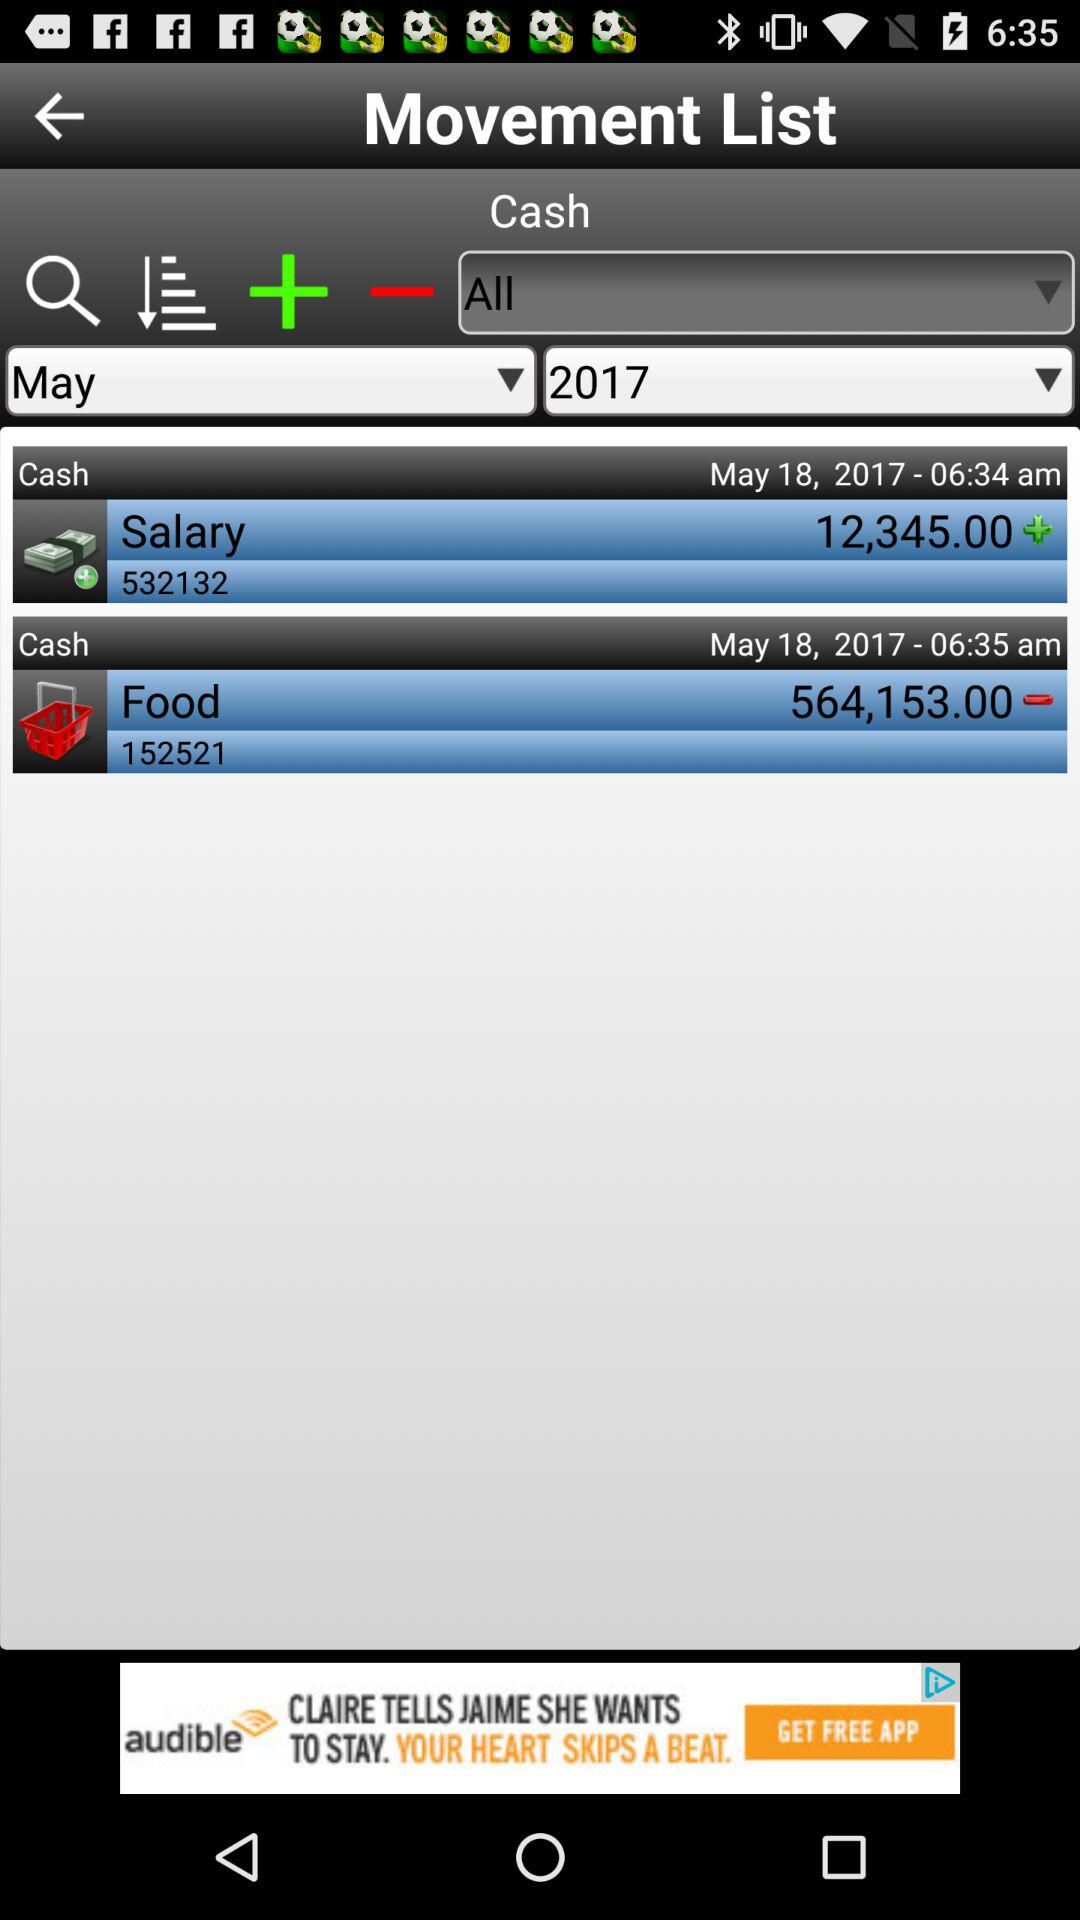What is the mode of transaction for paying food expenses? The mode of transaction for paying food expenses is cash. 